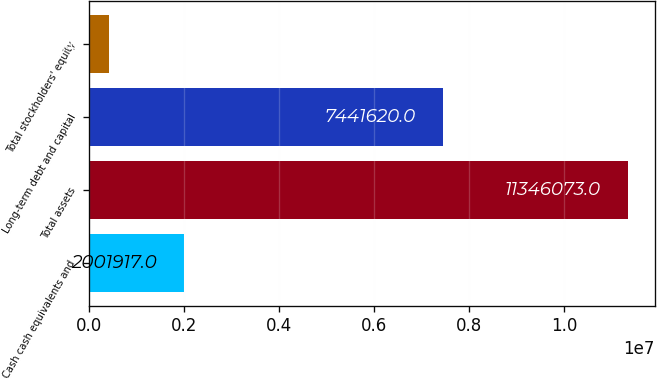Convert chart. <chart><loc_0><loc_0><loc_500><loc_500><bar_chart><fcel>Cash cash equivalents and<fcel>Total assets<fcel>Long-term debt and capital<fcel>Total stockholders' equity<nl><fcel>2.00192e+06<fcel>1.13461e+07<fcel>7.44162e+06<fcel>419003<nl></chart> 